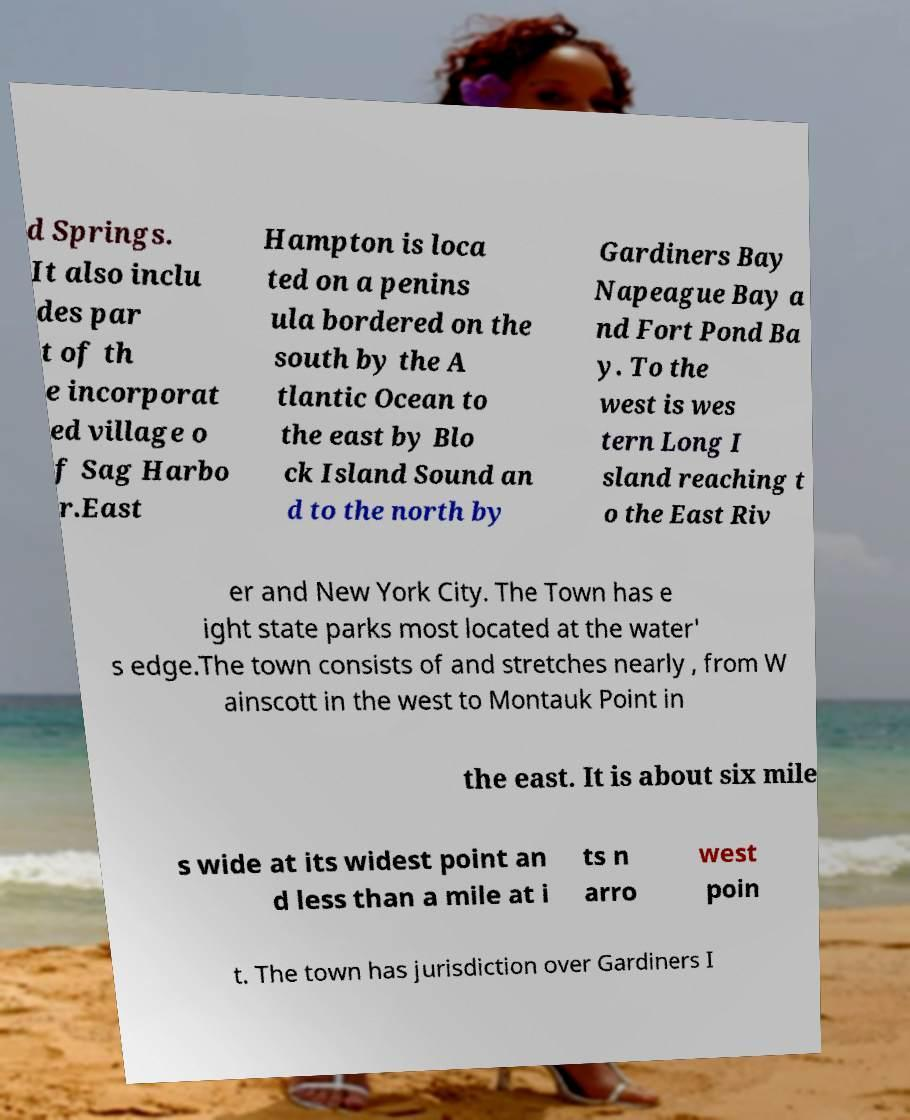I need the written content from this picture converted into text. Can you do that? d Springs. It also inclu des par t of th e incorporat ed village o f Sag Harbo r.East Hampton is loca ted on a penins ula bordered on the south by the A tlantic Ocean to the east by Blo ck Island Sound an d to the north by Gardiners Bay Napeague Bay a nd Fort Pond Ba y. To the west is wes tern Long I sland reaching t o the East Riv er and New York City. The Town has e ight state parks most located at the water' s edge.The town consists of and stretches nearly , from W ainscott in the west to Montauk Point in the east. It is about six mile s wide at its widest point an d less than a mile at i ts n arro west poin t. The town has jurisdiction over Gardiners I 